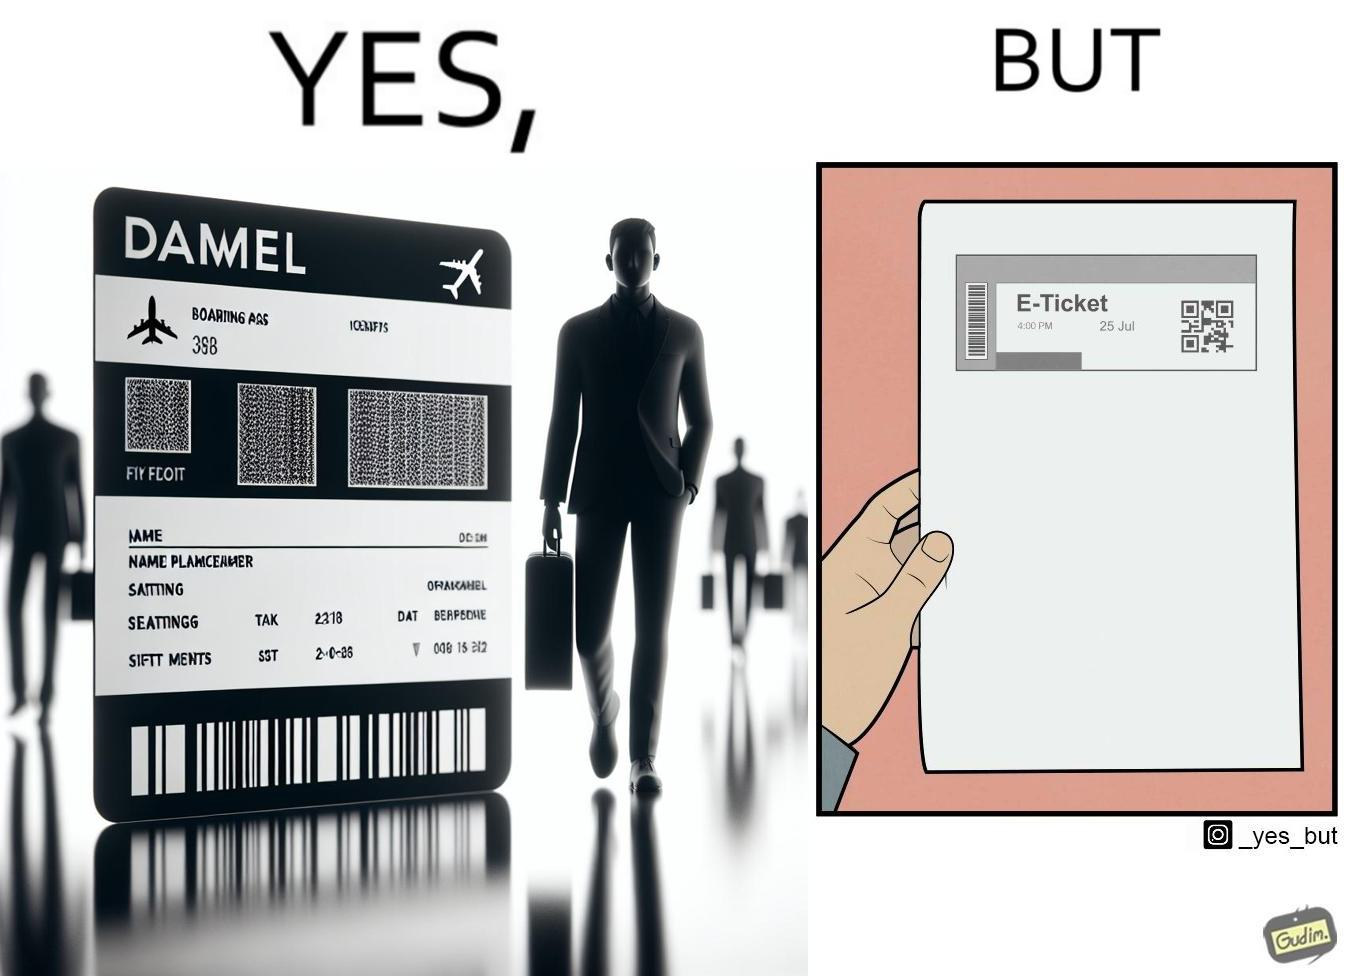Describe what you see in the left and right parts of this image. In the left part of the image: It is an e-ticket In the right part of the image: It is an e-ticket printed on paper 